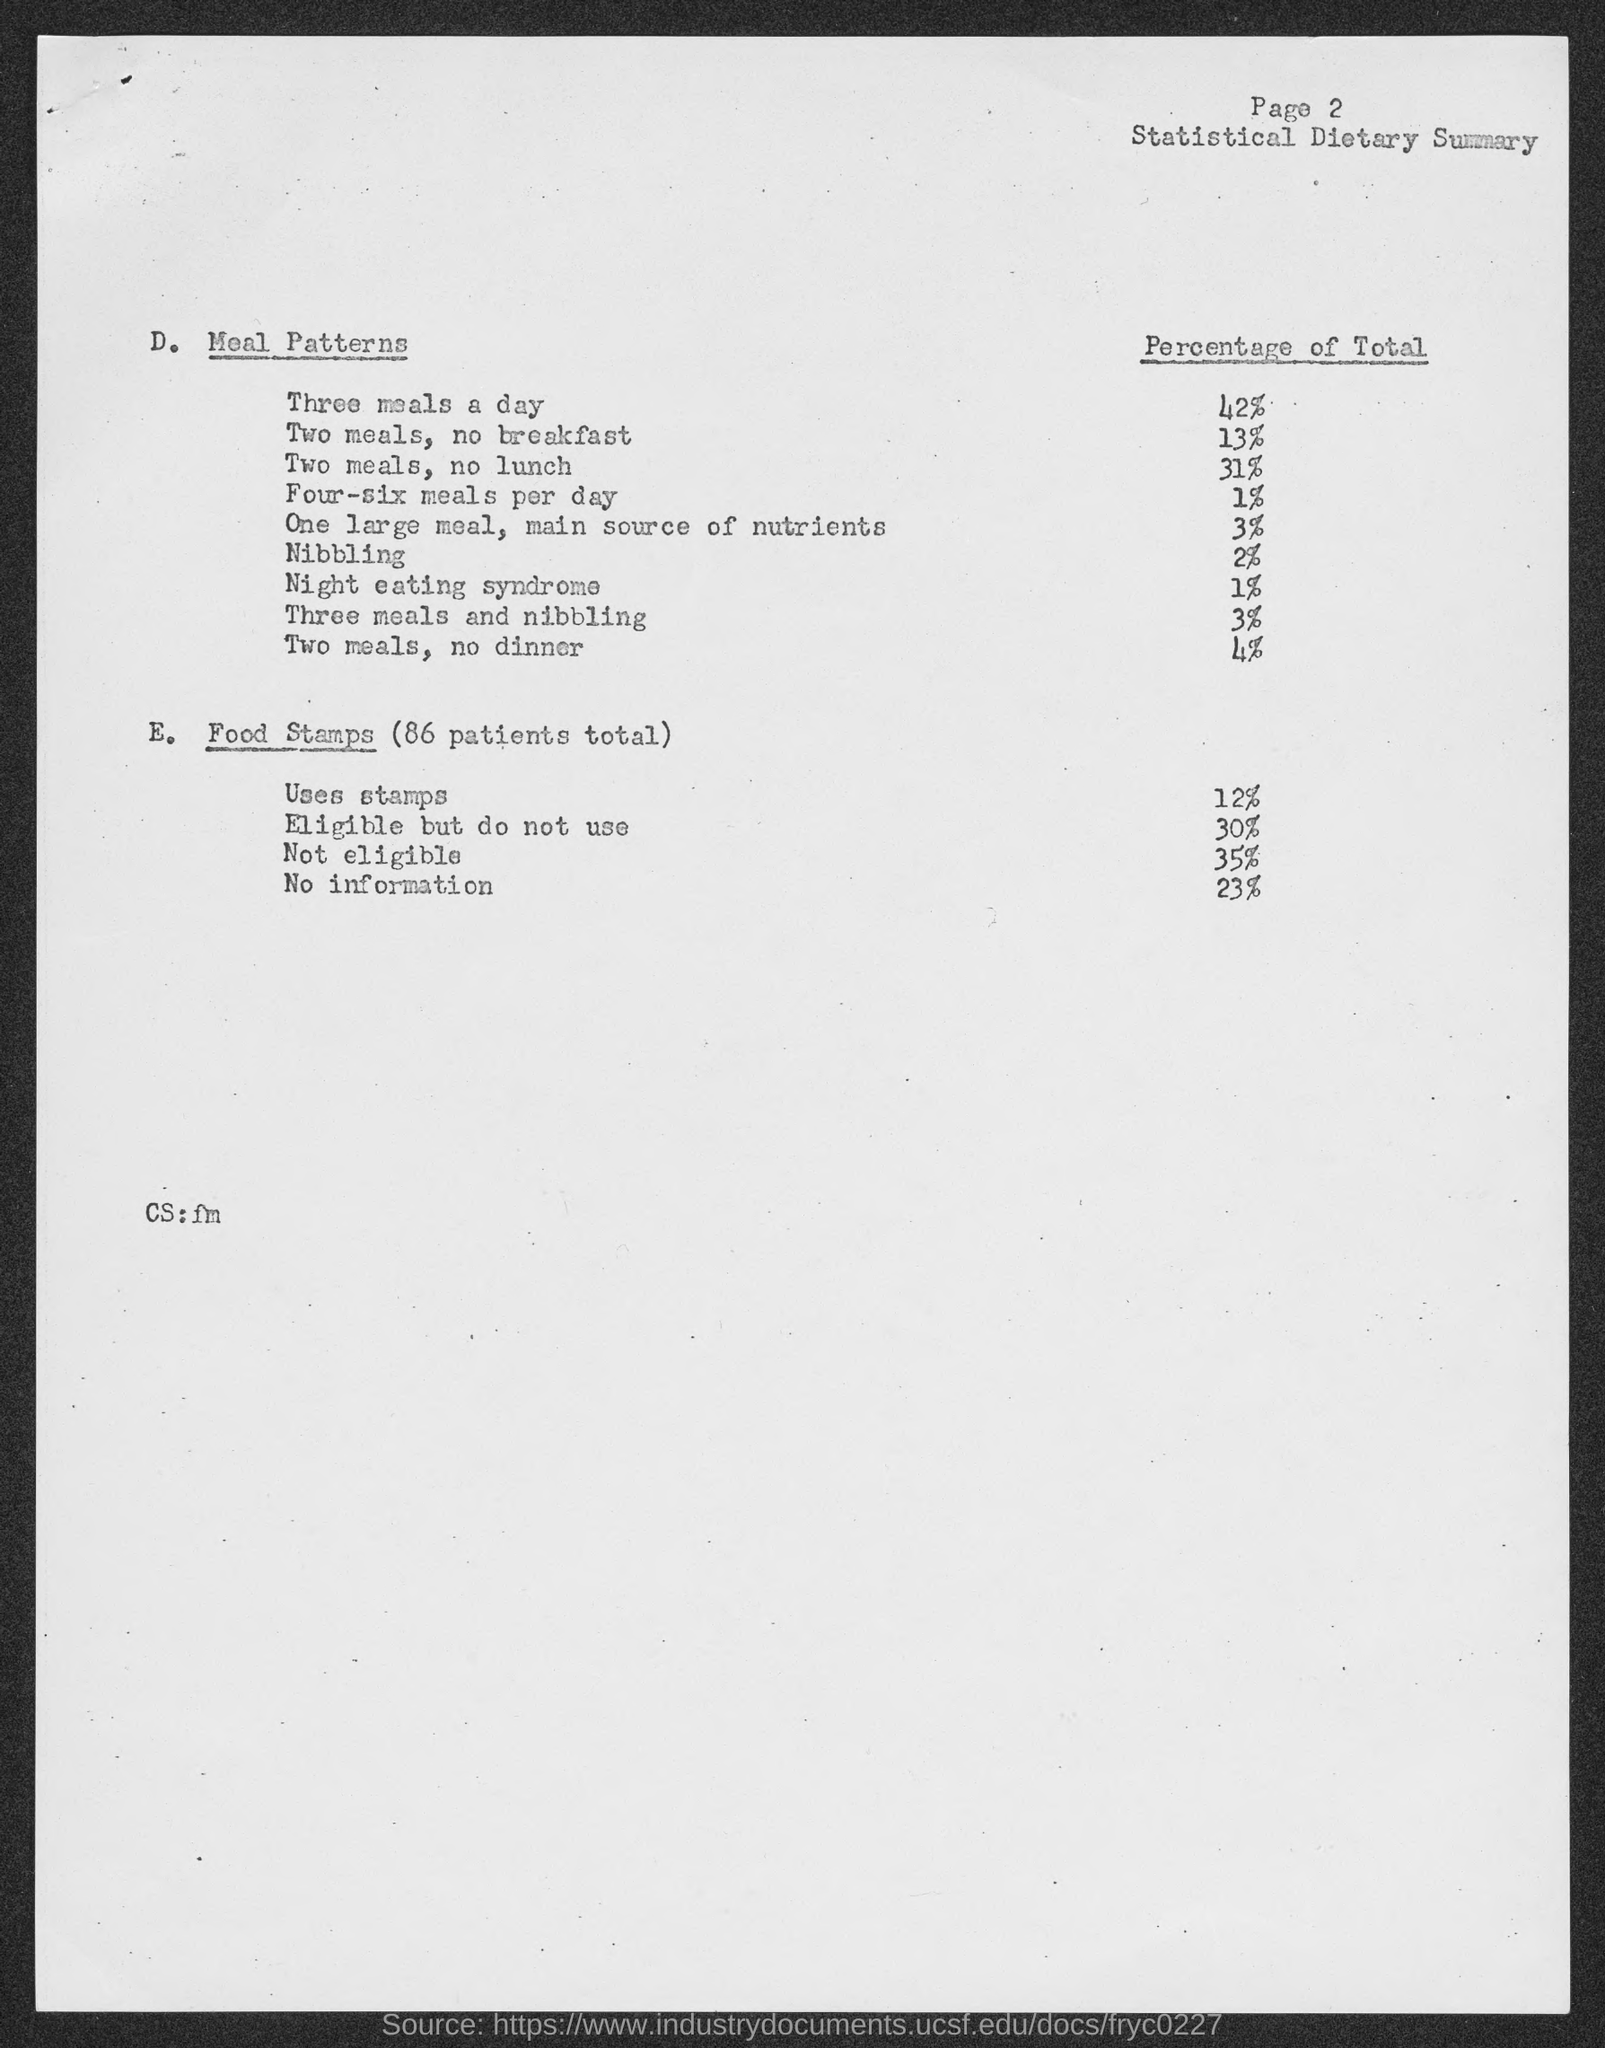What is the page no mentioned in this document?
Ensure brevity in your answer.  Page 2. What is the percentage of total of three meals a day meal pattern?
Your response must be concise. 42%. What is the percentage of total of Night eating syndrome?
Your response must be concise. 1%. 